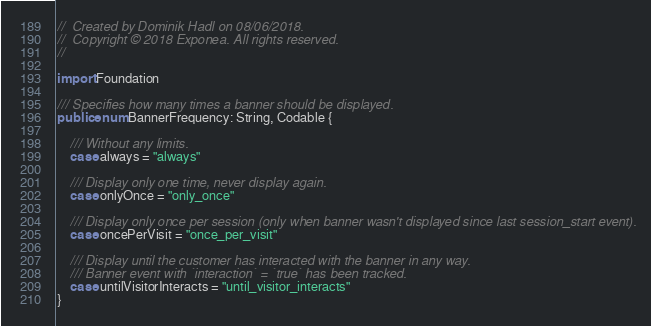Convert code to text. <code><loc_0><loc_0><loc_500><loc_500><_Swift_>//  Created by Dominik Hadl on 08/06/2018.
//  Copyright © 2018 Exponea. All rights reserved.
//

import Foundation

/// Specifies how many times a banner should be displayed.
public enum BannerFrequency: String, Codable {
    
    /// Without any limits.
    case always = "always"
    
    /// Display only one time, never display again.
    case onlyOnce = "only_once"
    
    /// Display only once per session (only when banner wasn't displayed since last session_start event).
    case oncePerVisit = "once_per_visit"
    
    /// Display until the customer has interacted with the banner in any way.
    /// Banner event with `interaction` = `true` has been tracked.
    case untilVisitorInteracts = "until_visitor_interacts"
}
</code> 